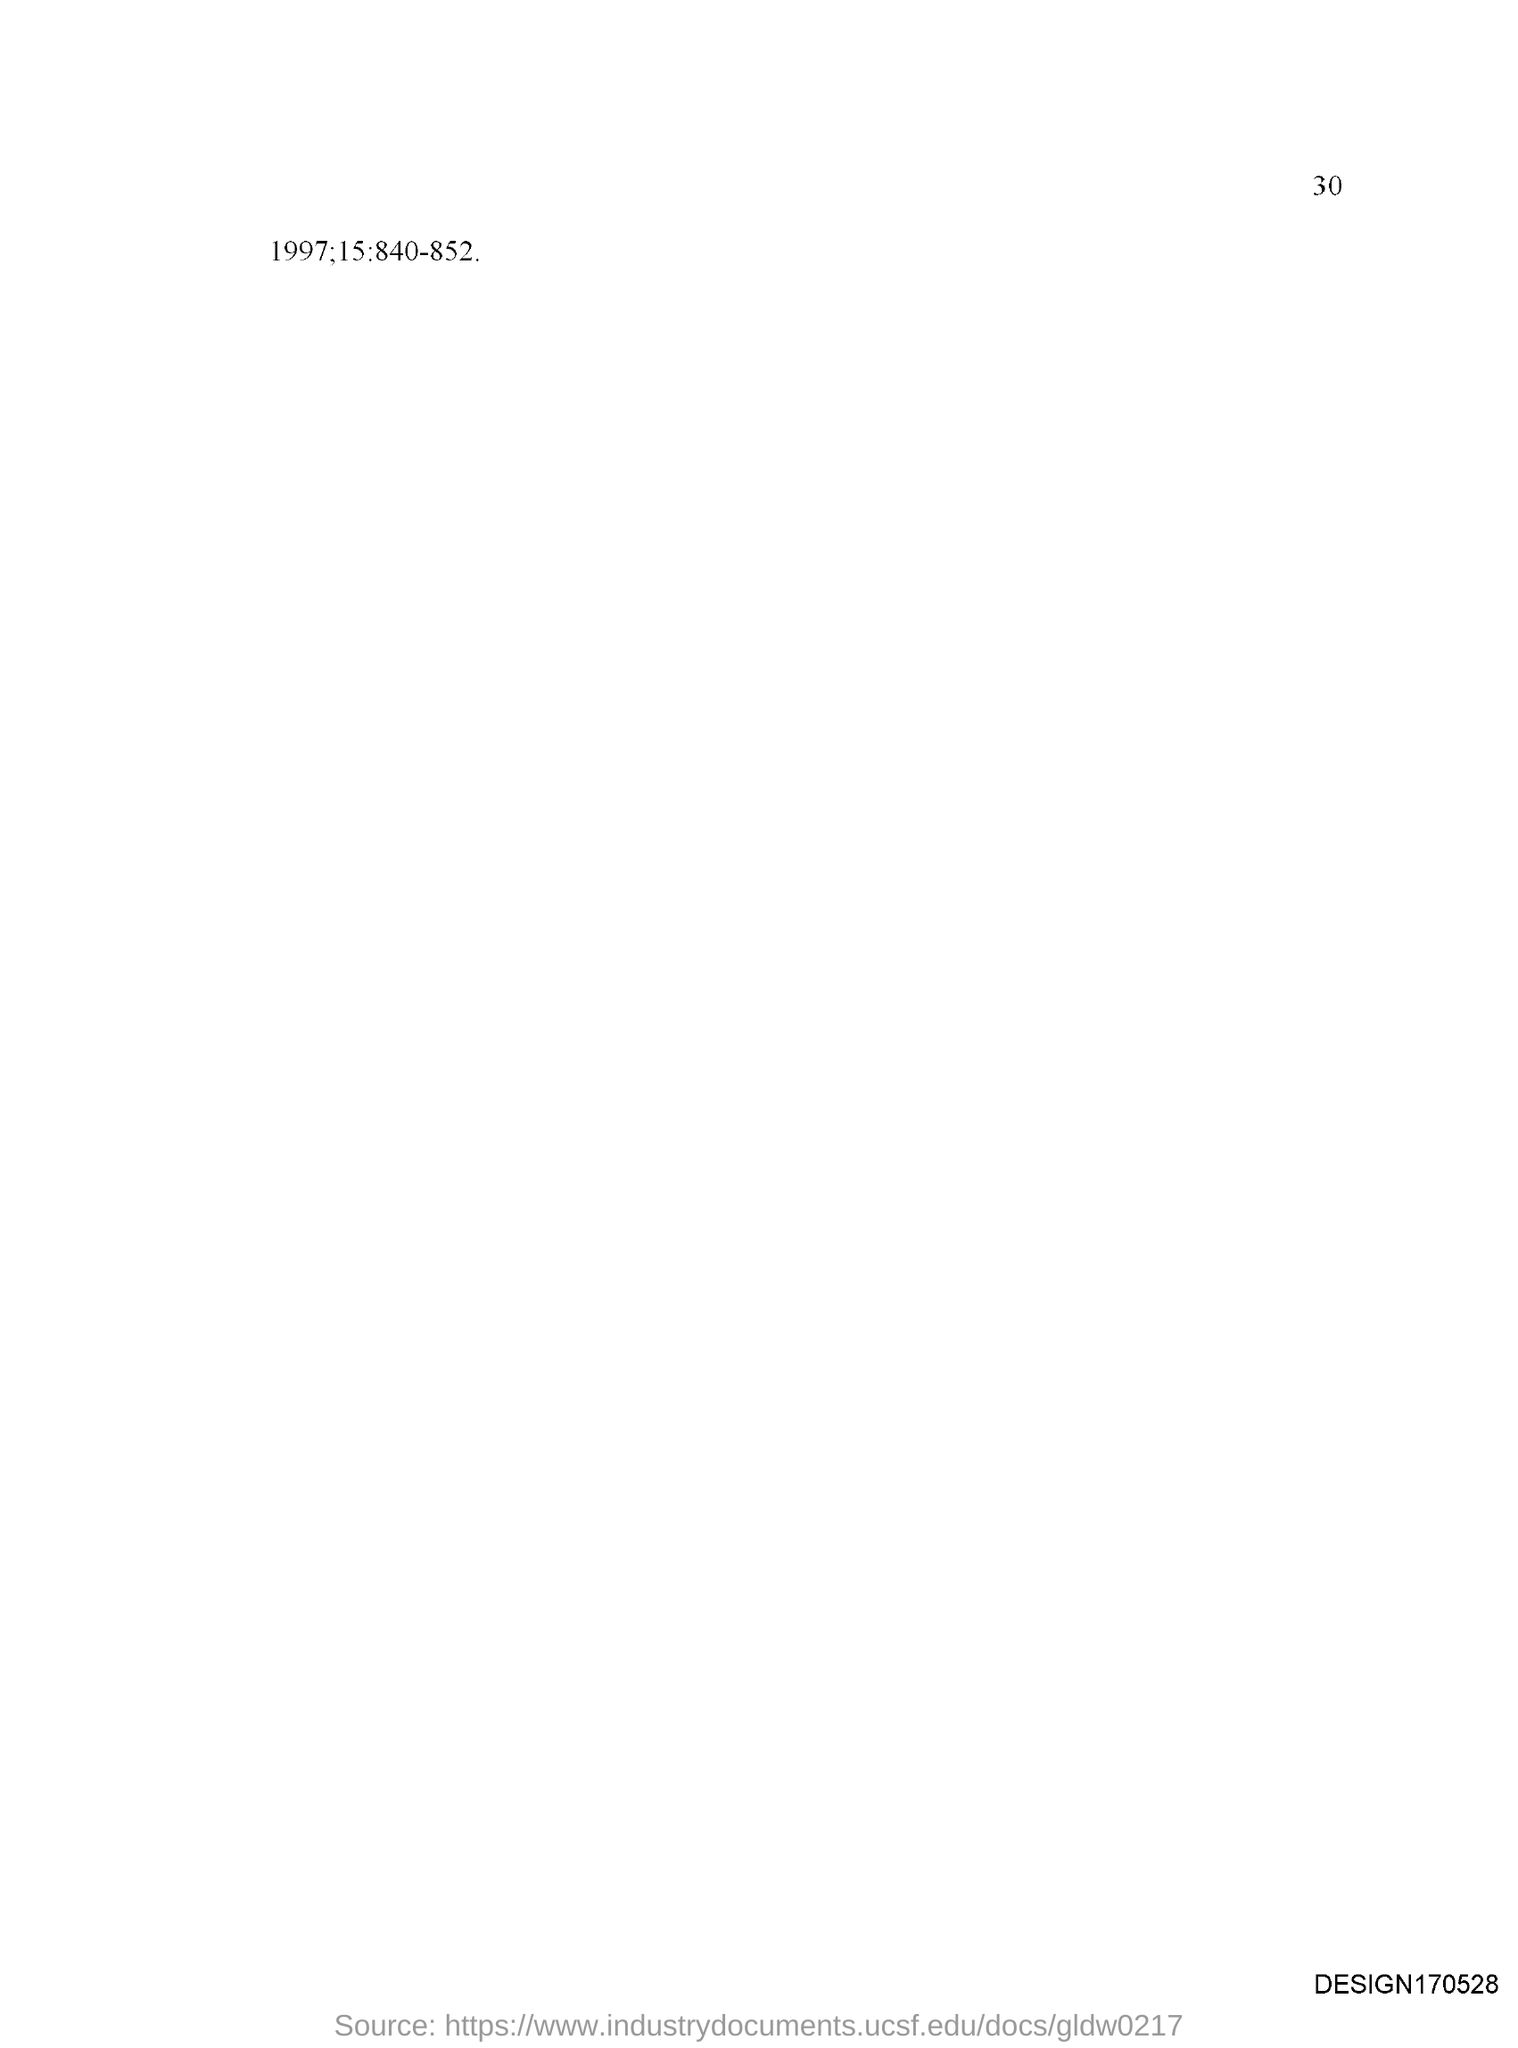Highlight a few significant elements in this photo. The document page number is 30, as stated in the declaration. 